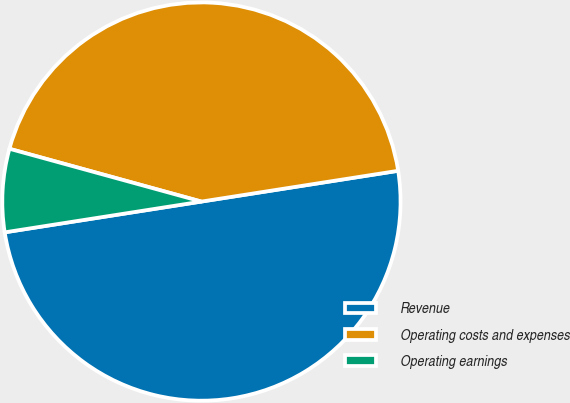<chart> <loc_0><loc_0><loc_500><loc_500><pie_chart><fcel>Revenue<fcel>Operating costs and expenses<fcel>Operating earnings<nl><fcel>50.0%<fcel>43.26%<fcel>6.74%<nl></chart> 